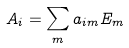Convert formula to latex. <formula><loc_0><loc_0><loc_500><loc_500>A _ { i } = \sum _ { m } a _ { i m } E _ { m }</formula> 